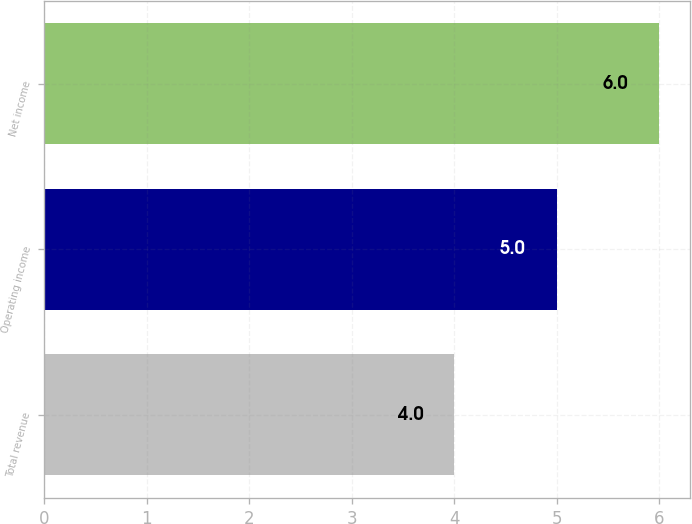Convert chart to OTSL. <chart><loc_0><loc_0><loc_500><loc_500><bar_chart><fcel>Total revenue<fcel>Operating income<fcel>Net income<nl><fcel>4<fcel>5<fcel>6<nl></chart> 